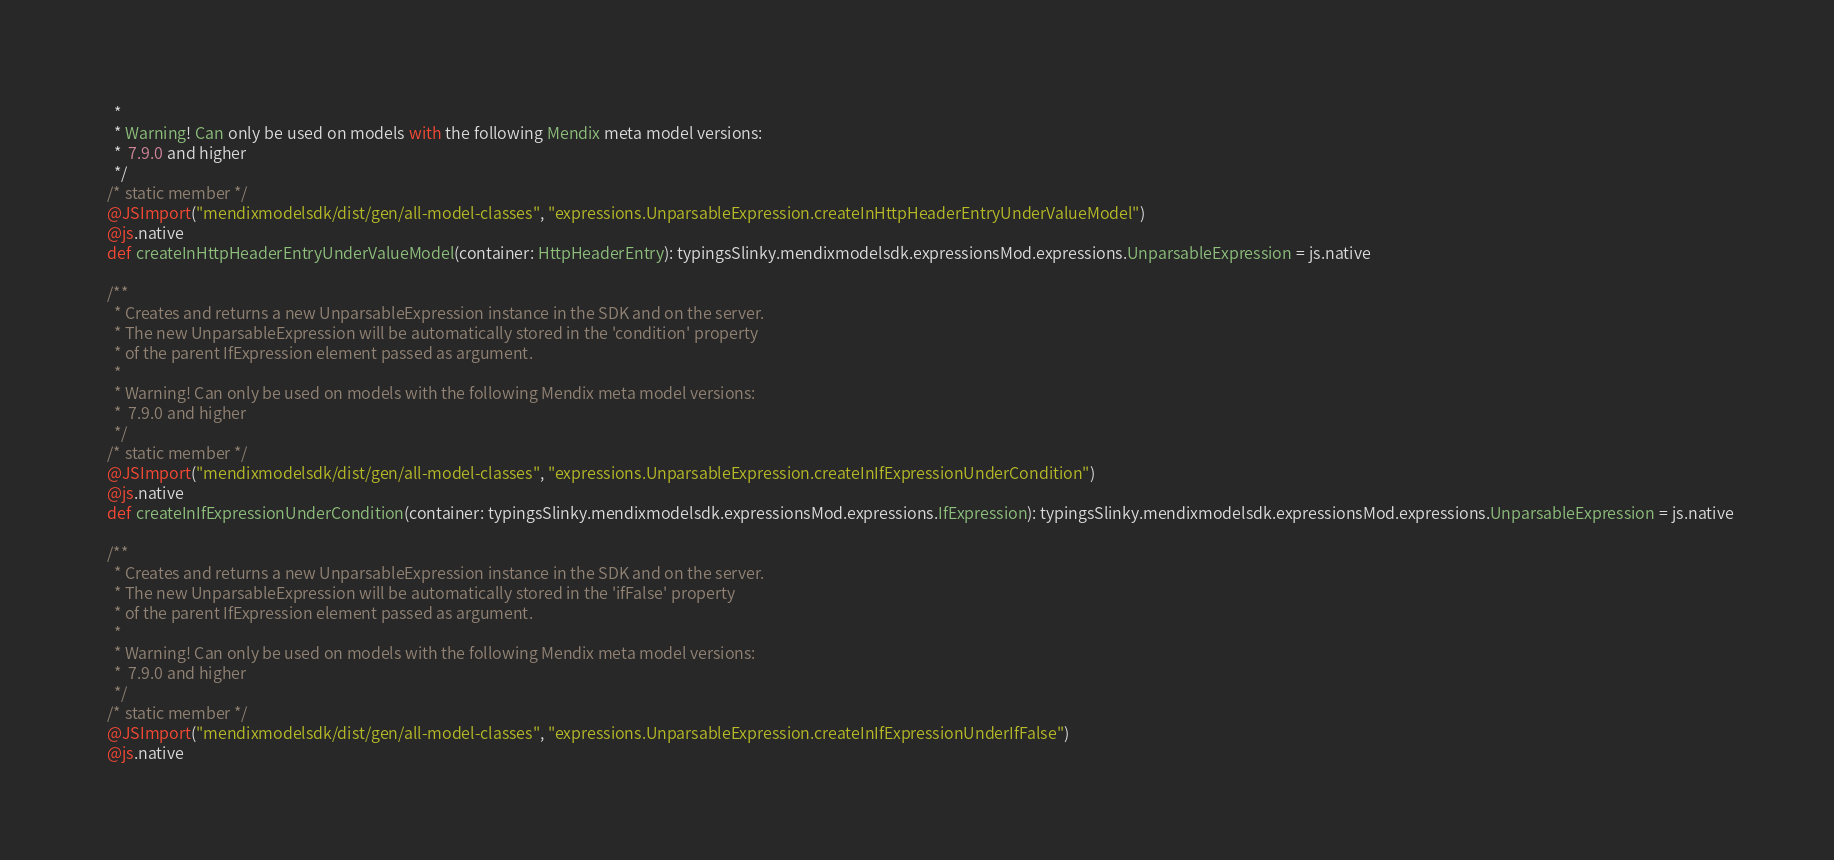<code> <loc_0><loc_0><loc_500><loc_500><_Scala_>    *
    * Warning! Can only be used on models with the following Mendix meta model versions:
    *  7.9.0 and higher
    */
  /* static member */
  @JSImport("mendixmodelsdk/dist/gen/all-model-classes", "expressions.UnparsableExpression.createInHttpHeaderEntryUnderValueModel")
  @js.native
  def createInHttpHeaderEntryUnderValueModel(container: HttpHeaderEntry): typingsSlinky.mendixmodelsdk.expressionsMod.expressions.UnparsableExpression = js.native
  
  /**
    * Creates and returns a new UnparsableExpression instance in the SDK and on the server.
    * The new UnparsableExpression will be automatically stored in the 'condition' property
    * of the parent IfExpression element passed as argument.
    *
    * Warning! Can only be used on models with the following Mendix meta model versions:
    *  7.9.0 and higher
    */
  /* static member */
  @JSImport("mendixmodelsdk/dist/gen/all-model-classes", "expressions.UnparsableExpression.createInIfExpressionUnderCondition")
  @js.native
  def createInIfExpressionUnderCondition(container: typingsSlinky.mendixmodelsdk.expressionsMod.expressions.IfExpression): typingsSlinky.mendixmodelsdk.expressionsMod.expressions.UnparsableExpression = js.native
  
  /**
    * Creates and returns a new UnparsableExpression instance in the SDK and on the server.
    * The new UnparsableExpression will be automatically stored in the 'ifFalse' property
    * of the parent IfExpression element passed as argument.
    *
    * Warning! Can only be used on models with the following Mendix meta model versions:
    *  7.9.0 and higher
    */
  /* static member */
  @JSImport("mendixmodelsdk/dist/gen/all-model-classes", "expressions.UnparsableExpression.createInIfExpressionUnderIfFalse")
  @js.native</code> 